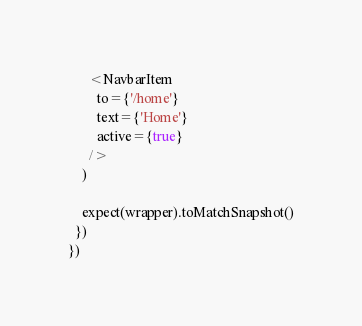Convert code to text. <code><loc_0><loc_0><loc_500><loc_500><_JavaScript_>      <NavbarItem
        to={'/home'}
        text={'Home'}
        active={true}
      />
    )

    expect(wrapper).toMatchSnapshot()
  })
})
</code> 